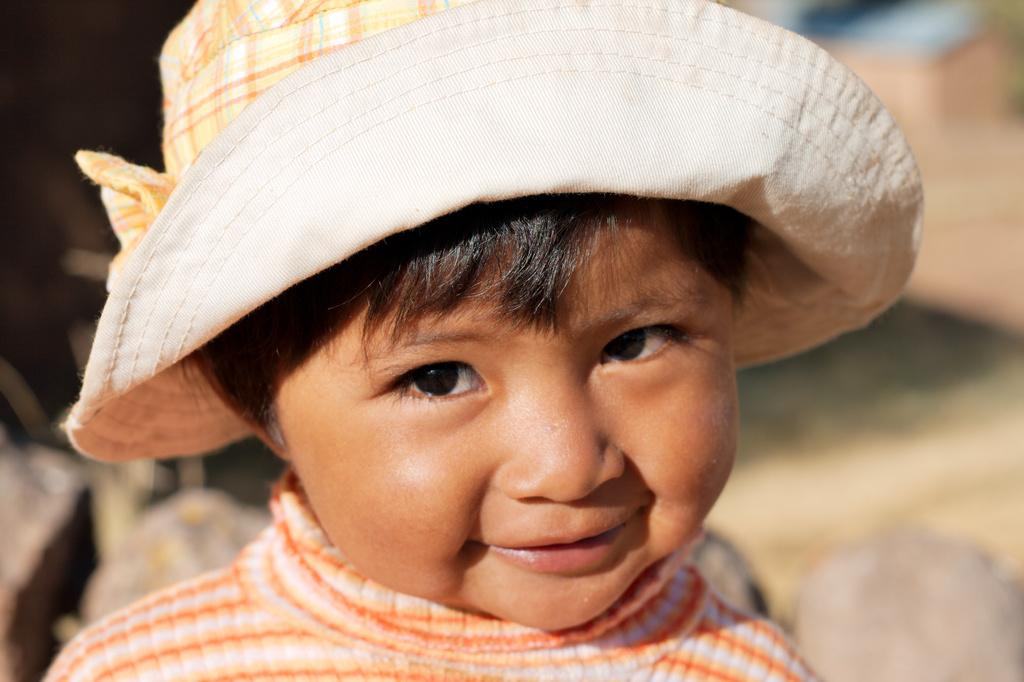Who is the main subject in the image? There is a girl in the image. What is the girl wearing on her head? The girl is wearing a hat. What is the girl's facial expression in the image? The girl is smiling. What is the girl doing in the image? The girl is posing for the photo. What can be seen behind the girl in the image? There are rocks visible behind the girl. How is the background of the image depicted? The background of the image is blurred. How many dogs are visible in the image? There are no dogs present in the image. What type of roof is visible in the image? There is no roof visible in the image. 